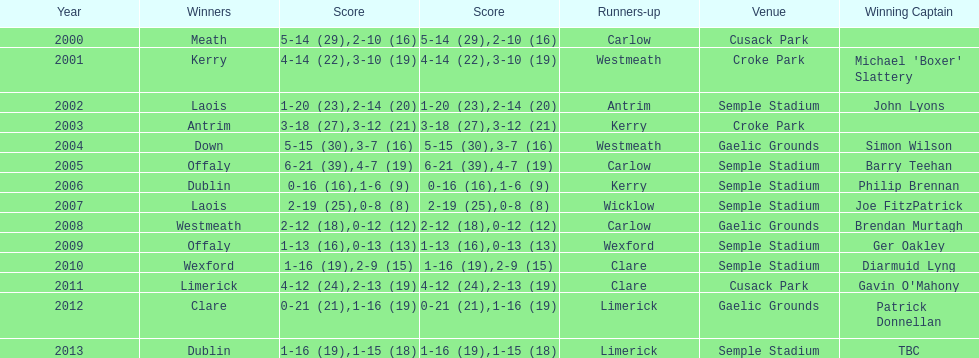Who was the initial victorious captain? Michael 'Boxer' Slattery. 